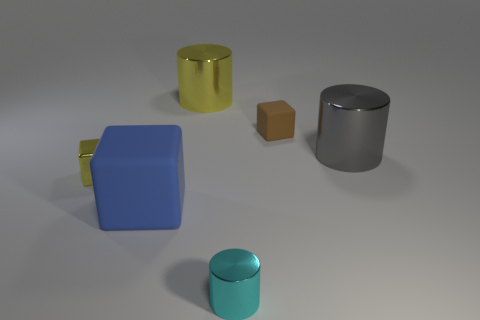Add 1 green shiny cylinders. How many objects exist? 7 Subtract all small yellow cubes. How many cubes are left? 2 Subtract 2 blocks. How many blocks are left? 1 Add 6 blue cubes. How many blue cubes are left? 7 Add 5 tiny metal cylinders. How many tiny metal cylinders exist? 6 Subtract all yellow cylinders. How many cylinders are left? 2 Subtract 0 gray balls. How many objects are left? 6 Subtract all red cubes. Subtract all yellow spheres. How many cubes are left? 3 Subtract all gray cylinders. How many blue cubes are left? 1 Subtract all big shiny cylinders. Subtract all brown cubes. How many objects are left? 3 